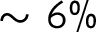Convert formula to latex. <formula><loc_0><loc_0><loc_500><loc_500>\sim 6 \%</formula> 